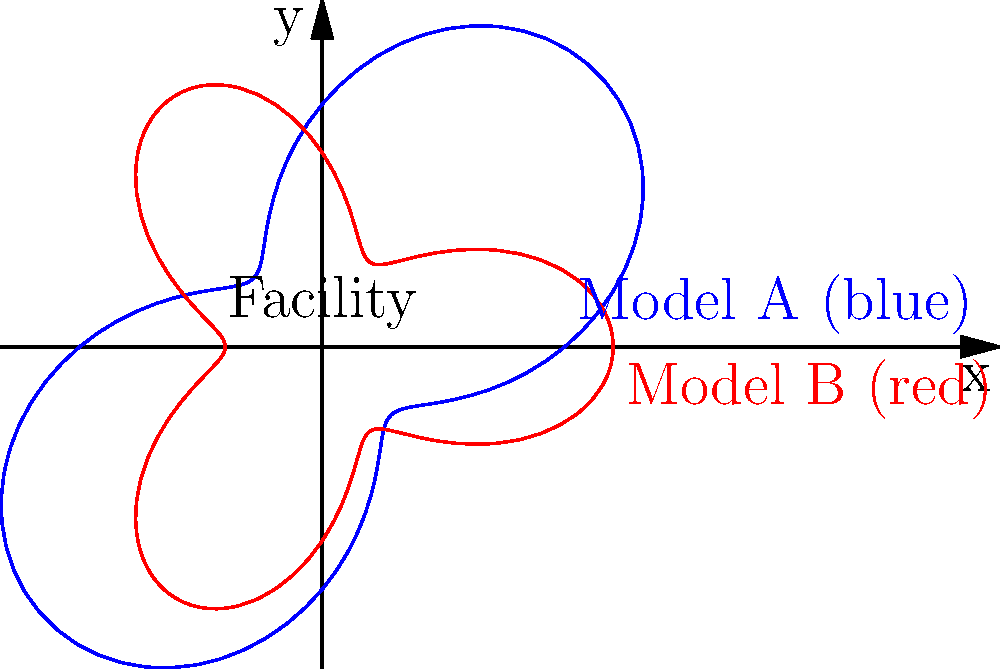The graph shows two models (A and B) for the radial spread of pollutants from a central waste processing facility. Model A is represented by the polar equation $r = 5 + 3\sin(2\theta)$, while Model B is represented by $r = 4 + 2\cos(3\theta)$. Which model predicts a greater maximum spread distance for the pollutants? To determine which model predicts a greater maximum spread distance, we need to find the maximum value of $r$ for each model:

1. For Model A: $r = 5 + 3\sin(2\theta)$
   - The maximum value occurs when $\sin(2\theta) = 1$
   - Maximum $r_A = 5 + 3 = 8$

2. For Model B: $r = 4 + 2\cos(3\theta)$
   - The maximum value occurs when $\cos(3\theta) = 1$
   - Maximum $r_B = 4 + 2 = 6$

3. Compare the maximum values:
   $r_A = 8 > r_B = 6$

Therefore, Model A predicts a greater maximum spread distance for the pollutants.
Answer: Model A 